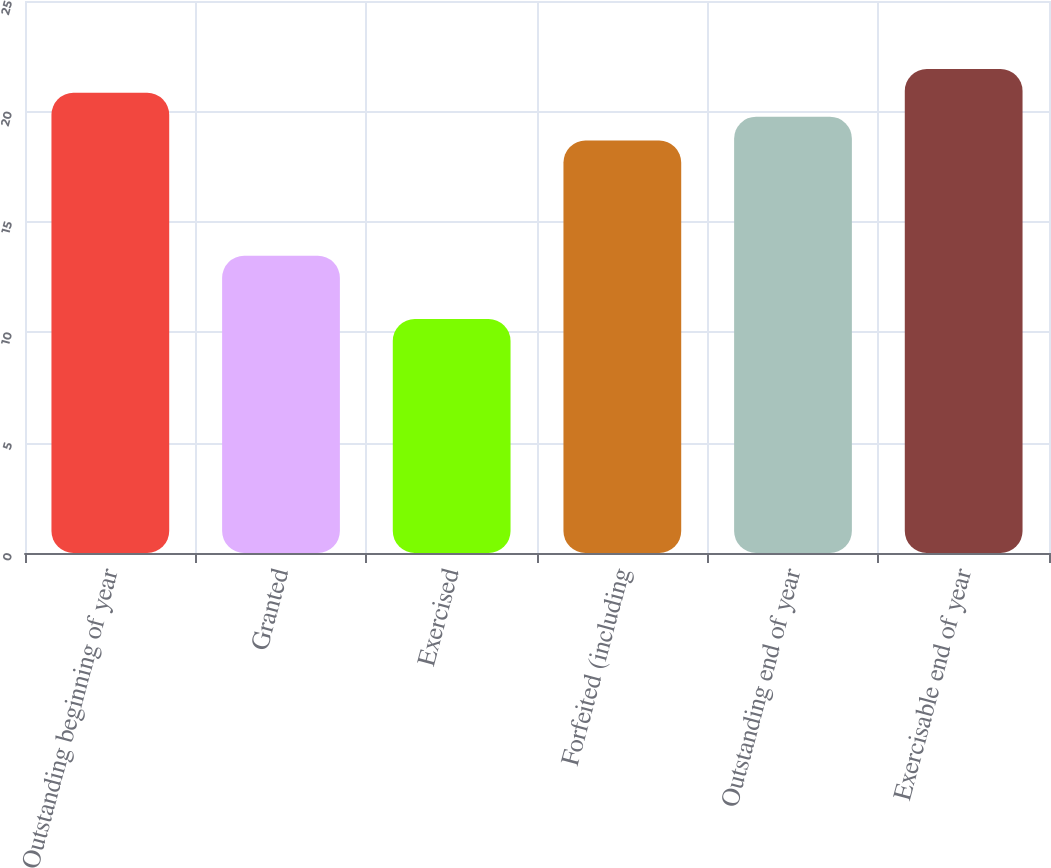Convert chart. <chart><loc_0><loc_0><loc_500><loc_500><bar_chart><fcel>Outstanding beginning of year<fcel>Granted<fcel>Exercised<fcel>Forfeited (including<fcel>Outstanding end of year<fcel>Exercisable end of year<nl><fcel>20.84<fcel>13.46<fcel>10.6<fcel>18.68<fcel>19.76<fcel>21.92<nl></chart> 